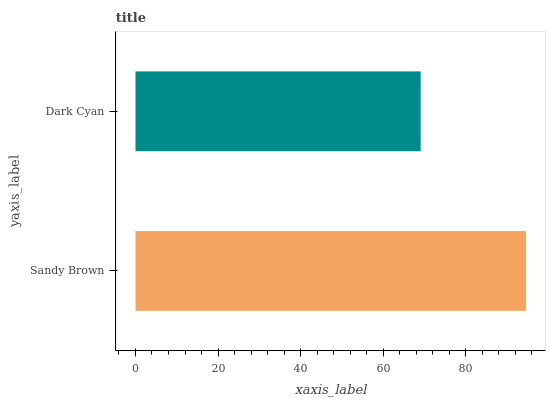Is Dark Cyan the minimum?
Answer yes or no. Yes. Is Sandy Brown the maximum?
Answer yes or no. Yes. Is Dark Cyan the maximum?
Answer yes or no. No. Is Sandy Brown greater than Dark Cyan?
Answer yes or no. Yes. Is Dark Cyan less than Sandy Brown?
Answer yes or no. Yes. Is Dark Cyan greater than Sandy Brown?
Answer yes or no. No. Is Sandy Brown less than Dark Cyan?
Answer yes or no. No. Is Sandy Brown the high median?
Answer yes or no. Yes. Is Dark Cyan the low median?
Answer yes or no. Yes. Is Dark Cyan the high median?
Answer yes or no. No. Is Sandy Brown the low median?
Answer yes or no. No. 